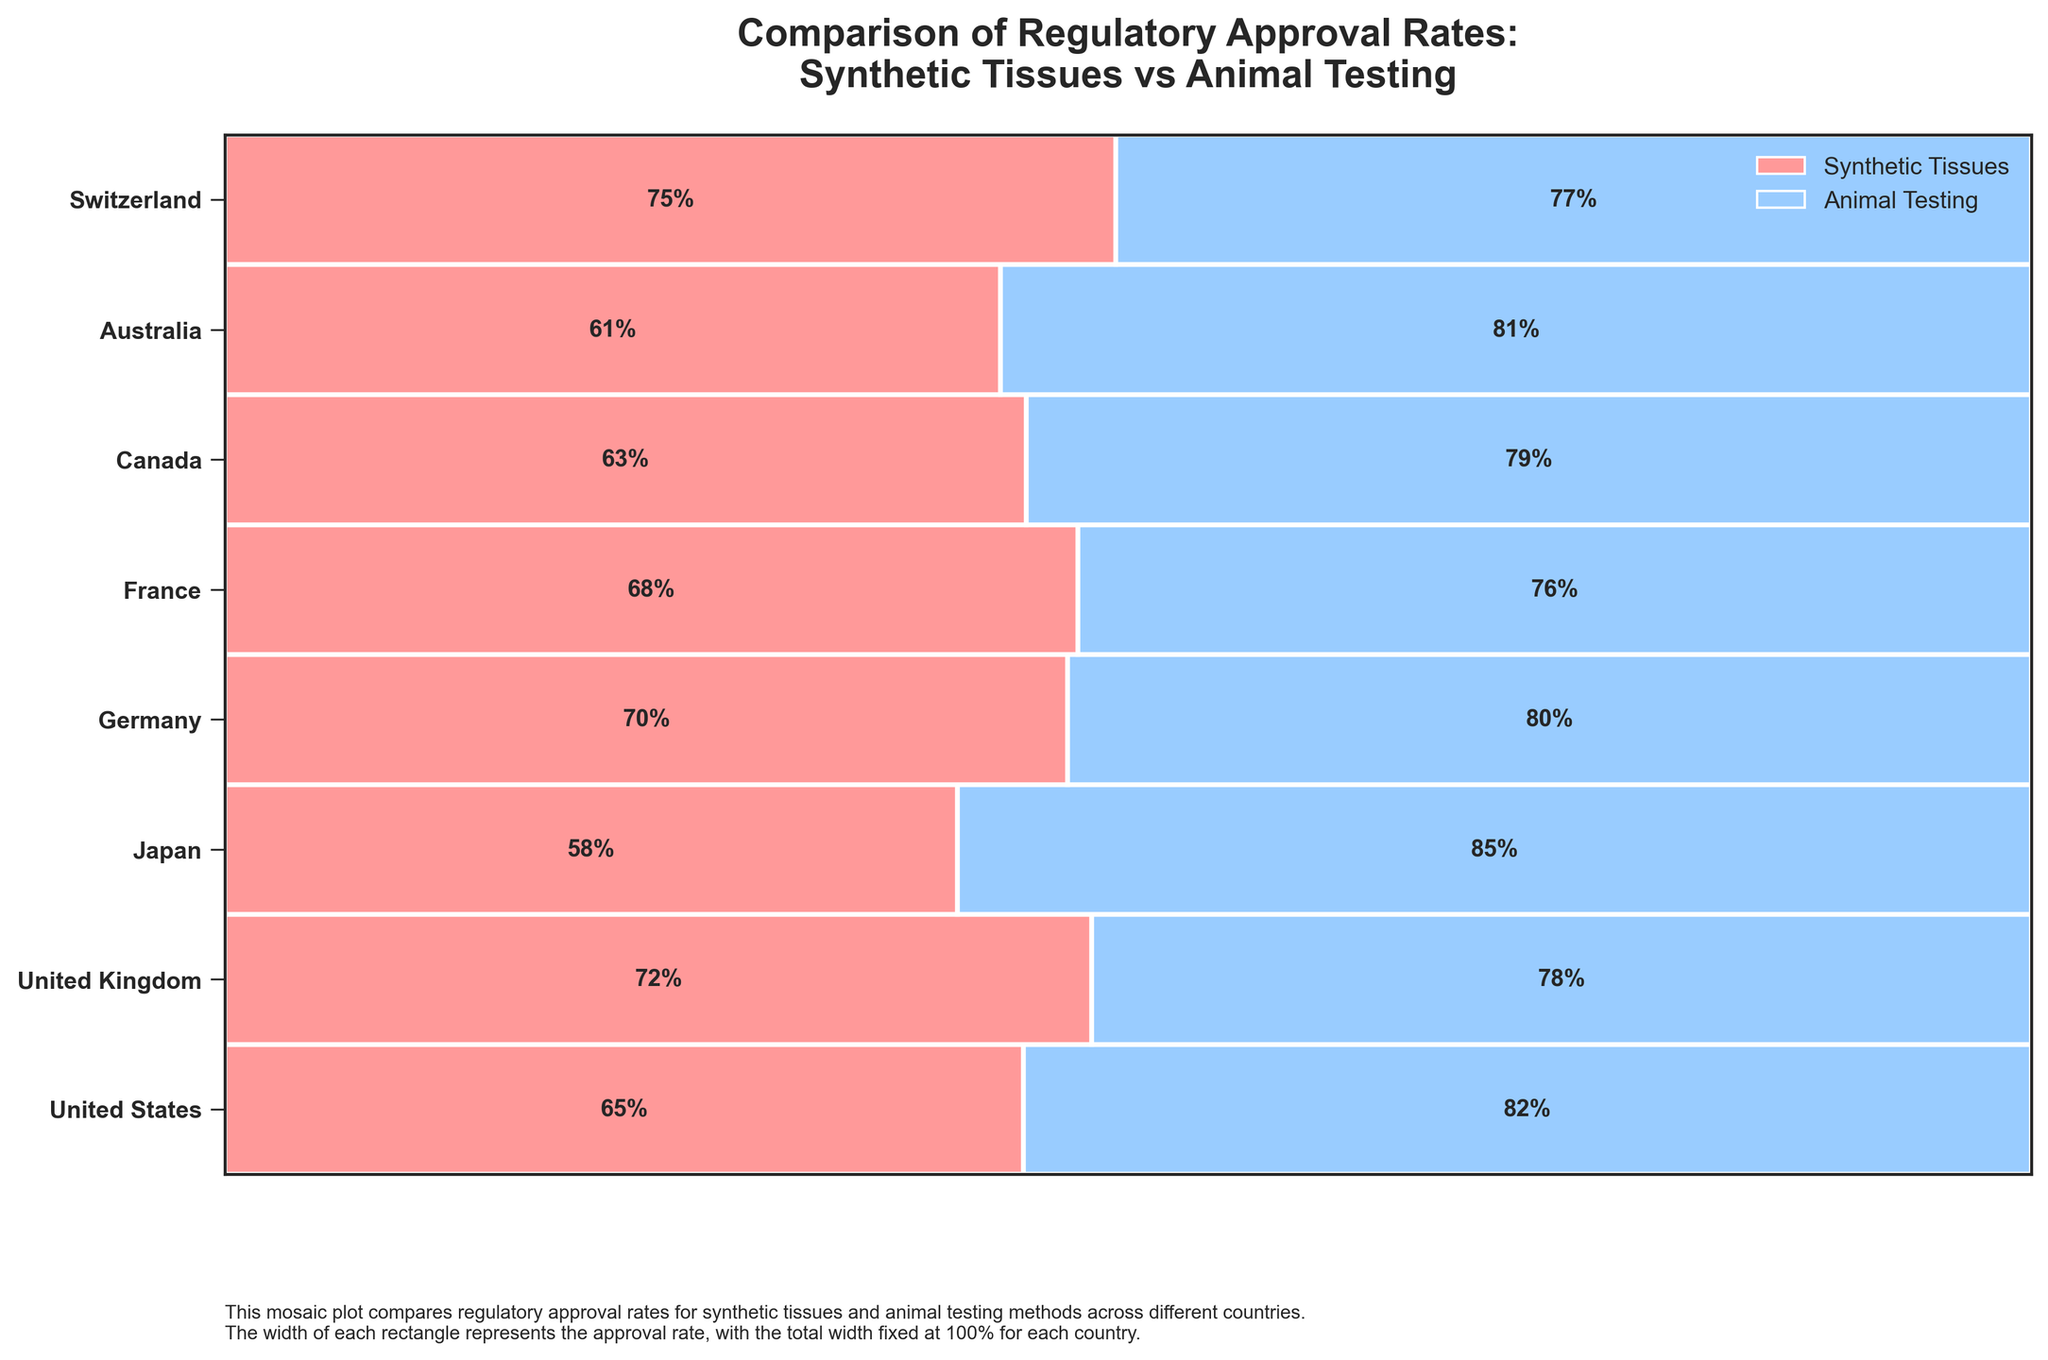What's the approval rate for synthetic tissues in the United States? Locate the rectangle representing the United States. The left part of the rectangle for each country indicates the approval rate for synthetic tissues. The text inside this rectangle shows the approval rate. For the United States, it is labeled as 65%.
Answer: 65% Which country has the highest approval rate for synthetic tissues and what is it? Compare the approval rates for synthetic tissues (the left side of each rectangle) across all countries. Identify the highest percentage value. Switzerland has the highest approval rate for synthetic tissues, labeled as 75%.
Answer: Switzerland, 75% Between the United Kingdom and Germany, which has a higher approval rate for animal testing? Locate the rectangles for the United Kingdom and Germany. The right part of each rectangle shows the approval rate for animal testing. Compare the values, which are 78% for the United Kingdom and 80% for Germany.
Answer: Germany What’s the difference in approval rates for synthetic tissues between Japan and France? Locate the rectangles for Japan and France. The left parts of these rectangles indicate the approval rates for synthetic tissues. Subtract Japan's rate (58%) from France's rate (68%). The difference is 68% - 58% = 10%.
Answer: 10% How many countries have an approval rate for synthetic tissues above 65%? Review each rectangle's left part to identify countries with approval rates for synthetic tissues above 65%. These countries are the United Kingdom (72%), Germany (70%), France (68%), and Switzerland (75%). There are four such countries.
Answer: 4 Which testing method generally has higher approval rates across the countries? Visually inspect the widths of the rectangles in each country. The right side (animal testing) generally appears wider than the left side (synthetic tissues), indicating higher approval rates for animal testing.
Answer: Animal testing Which country has the smallest difference in approval rates between synthetic tissues and animal testing? For each country, calculate the difference between the approval rates of synthetic tissues and animal testing. The smallest difference is in Switzerland (77% - 75% = 2%).
Answer: Switzerland What is the average approval rate for synthetic tissues across all countries? Add all the synthetic tissue approval rates: 65% (US) + 72% (UK) + 58% (Japan) + 70% (Germany) + 68% (France) + 63% (Canada) + 61% (Australia) + 75% (Switzerland) = 532%. Divide by the number of countries (8). 532% / 8 = 66.5%.
Answer: 66.5% Which country has the largest approval rate difference favoring animal testing? Calculate the difference between animal testing and synthetic tissues for each country. The largest difference is for Japan (85% - 58% = 27%).
Answer: Japan For which countries are the approval rates for animal testing and synthetic tissues the closest, and what is their difference? Calculate the absolute differences for each country: US (82 - 65 = 17), UK (78 - 72 = 6), Japan (85 - 58 = 27), Germany (80 - 70 = 10), France (76 - 68 = 8), Canada (79 - 63 = 16), Australia (81 - 61 = 20), Switzerland (77 - 75 = 2). The smallest difference is Switzerland with a difference of 2%.
Answer: Switzerland, 2% 